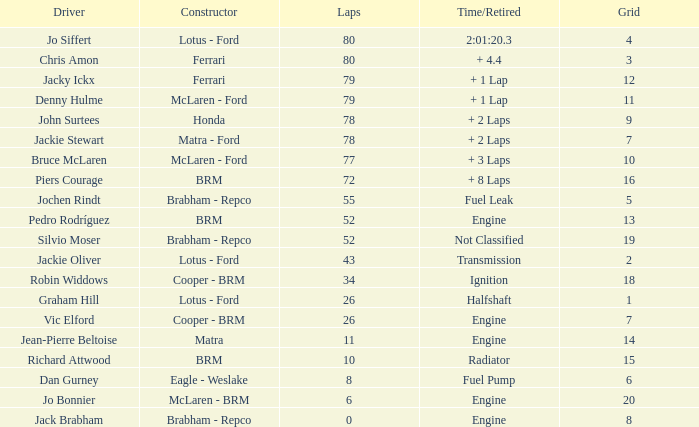What driver holds a grid exceeding 19? Jo Bonnier. 